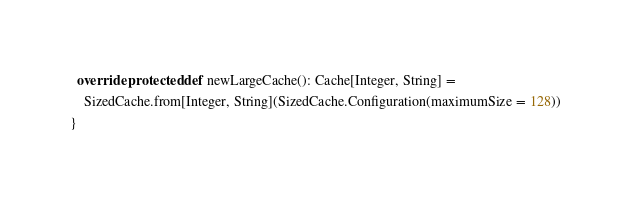<code> <loc_0><loc_0><loc_500><loc_500><_Scala_>
  override protected def newLargeCache(): Cache[Integer, String] =
    SizedCache.from[Integer, String](SizedCache.Configuration(maximumSize = 128))
}
</code> 